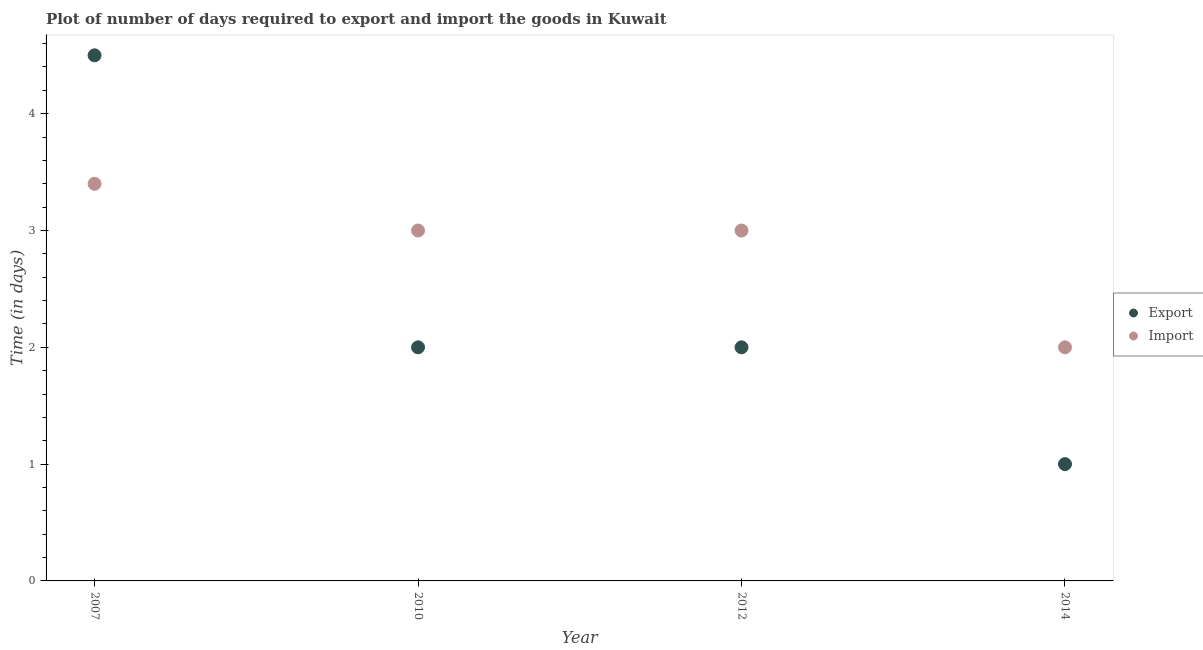How many different coloured dotlines are there?
Make the answer very short. 2. Is the number of dotlines equal to the number of legend labels?
Offer a very short reply. Yes. Across all years, what is the minimum time required to import?
Your answer should be compact. 2. What is the total time required to import in the graph?
Provide a succinct answer. 11.4. What is the difference between the time required to export in 2007 and that in 2010?
Provide a succinct answer. 2.5. What is the difference between the time required to export in 2010 and the time required to import in 2012?
Give a very brief answer. -1. What is the average time required to export per year?
Make the answer very short. 2.38. In the year 2012, what is the difference between the time required to import and time required to export?
Give a very brief answer. 1. In how many years, is the time required to export greater than 0.2 days?
Give a very brief answer. 4. Is the time required to export in 2012 less than that in 2014?
Ensure brevity in your answer.  No. Is the difference between the time required to export in 2010 and 2012 greater than the difference between the time required to import in 2010 and 2012?
Give a very brief answer. No. Is the sum of the time required to export in 2007 and 2014 greater than the maximum time required to import across all years?
Your answer should be very brief. Yes. Is the time required to import strictly less than the time required to export over the years?
Give a very brief answer. No. How many years are there in the graph?
Provide a short and direct response. 4. What is the difference between two consecutive major ticks on the Y-axis?
Give a very brief answer. 1. Are the values on the major ticks of Y-axis written in scientific E-notation?
Offer a very short reply. No. Does the graph contain grids?
Ensure brevity in your answer.  No. Where does the legend appear in the graph?
Provide a short and direct response. Center right. How are the legend labels stacked?
Make the answer very short. Vertical. What is the title of the graph?
Provide a short and direct response. Plot of number of days required to export and import the goods in Kuwait. Does "Merchandise exports" appear as one of the legend labels in the graph?
Give a very brief answer. No. What is the label or title of the X-axis?
Provide a short and direct response. Year. What is the label or title of the Y-axis?
Your answer should be compact. Time (in days). What is the Time (in days) of Import in 2007?
Your answer should be compact. 3.4. What is the Time (in days) in Import in 2010?
Give a very brief answer. 3. What is the Time (in days) in Export in 2012?
Your answer should be very brief. 2. What is the Time (in days) of Export in 2014?
Your answer should be very brief. 1. Across all years, what is the maximum Time (in days) of Export?
Keep it short and to the point. 4.5. Across all years, what is the maximum Time (in days) of Import?
Provide a short and direct response. 3.4. What is the difference between the Time (in days) of Export in 2007 and that in 2012?
Give a very brief answer. 2.5. What is the difference between the Time (in days) in Export in 2010 and that in 2012?
Your response must be concise. 0. What is the difference between the Time (in days) in Export in 2010 and that in 2014?
Offer a terse response. 1. What is the difference between the Time (in days) in Import in 2010 and that in 2014?
Provide a short and direct response. 1. What is the difference between the Time (in days) of Export in 2007 and the Time (in days) of Import in 2014?
Ensure brevity in your answer.  2.5. What is the difference between the Time (in days) of Export in 2010 and the Time (in days) of Import in 2012?
Your response must be concise. -1. What is the difference between the Time (in days) of Export in 2012 and the Time (in days) of Import in 2014?
Keep it short and to the point. 0. What is the average Time (in days) of Export per year?
Make the answer very short. 2.38. What is the average Time (in days) of Import per year?
Offer a very short reply. 2.85. In the year 2012, what is the difference between the Time (in days) in Export and Time (in days) in Import?
Your answer should be compact. -1. What is the ratio of the Time (in days) in Export in 2007 to that in 2010?
Provide a succinct answer. 2.25. What is the ratio of the Time (in days) in Import in 2007 to that in 2010?
Keep it short and to the point. 1.13. What is the ratio of the Time (in days) of Export in 2007 to that in 2012?
Keep it short and to the point. 2.25. What is the ratio of the Time (in days) of Import in 2007 to that in 2012?
Keep it short and to the point. 1.13. What is the ratio of the Time (in days) of Export in 2010 to that in 2012?
Your response must be concise. 1. What is the ratio of the Time (in days) of Import in 2010 to that in 2012?
Provide a short and direct response. 1. What is the ratio of the Time (in days) in Export in 2010 to that in 2014?
Keep it short and to the point. 2. What is the ratio of the Time (in days) of Import in 2010 to that in 2014?
Your answer should be very brief. 1.5. What is the ratio of the Time (in days) in Export in 2012 to that in 2014?
Offer a very short reply. 2. What is the ratio of the Time (in days) of Import in 2012 to that in 2014?
Your response must be concise. 1.5. What is the difference between the highest and the lowest Time (in days) in Export?
Offer a terse response. 3.5. What is the difference between the highest and the lowest Time (in days) of Import?
Make the answer very short. 1.4. 